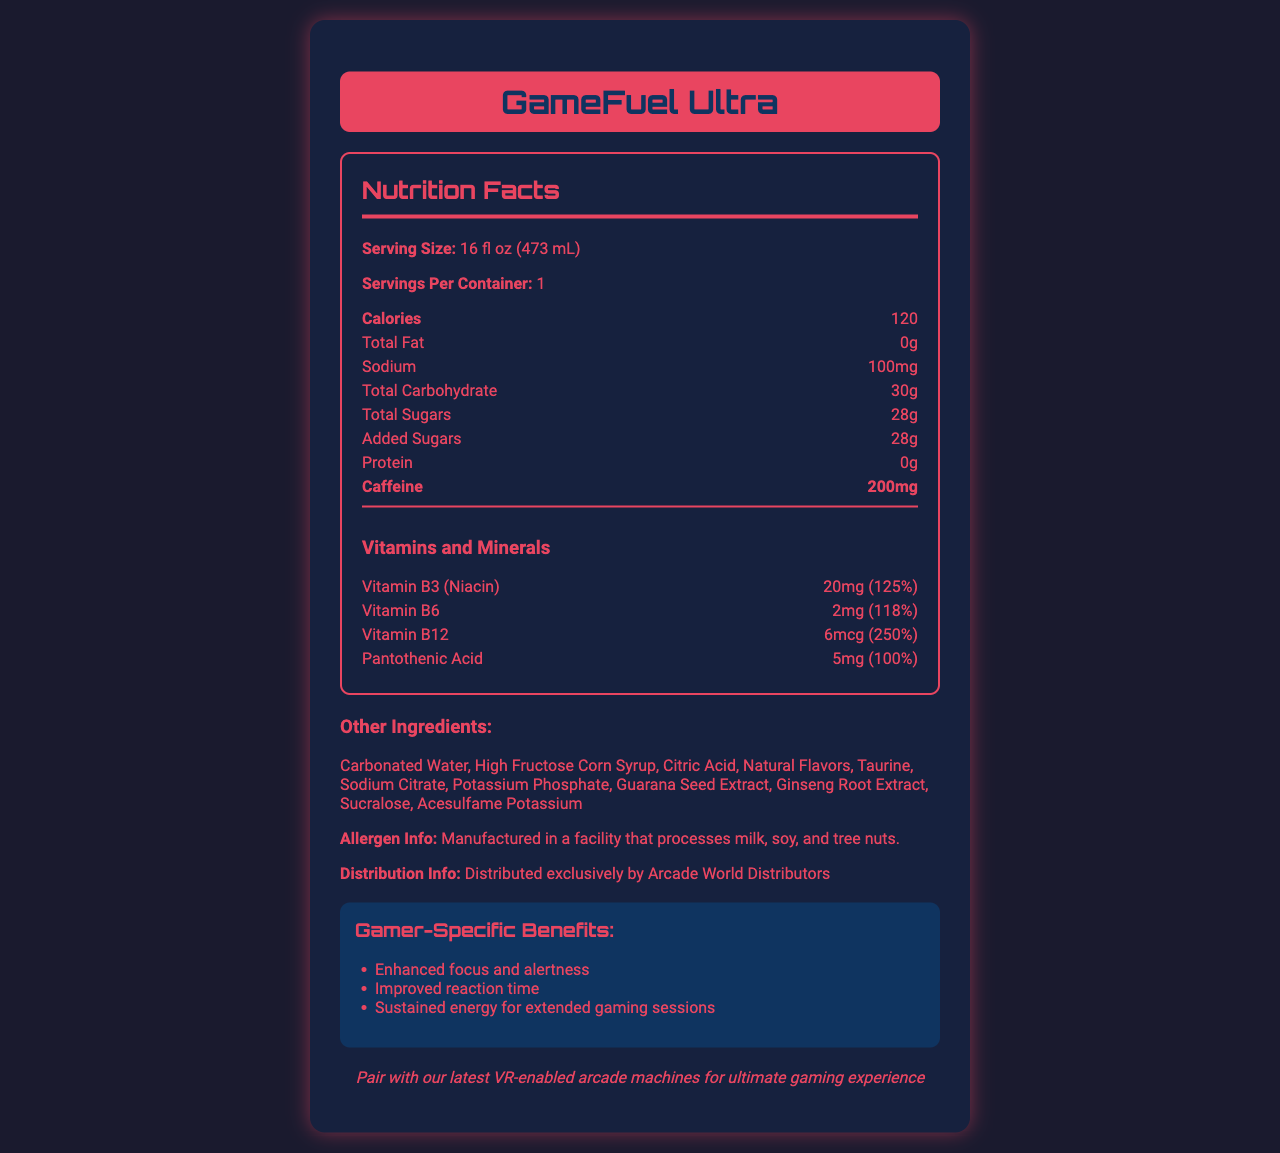what is the serving size of GameFuel Ultra? The document states that the serving size is "16 fl oz (473 mL)".
Answer: 16 fl oz (473 mL) how much caffeine does GameFuel Ultra contain per serving? The document lists the caffeine content as 200mg.
Answer: 200mg how many grams of total sugars are in GameFuel Ultra? The document states that the total sugars are 28g.
Answer: 28g how much sodium is present in one serving of GameFuel Ultra? The sodium content is listed as 100mg.
Answer: 100mg what is the calorie count for one container of GameFuel Ultra? The document specifies that the calorie count per serving is 120.
Answer: 120 which vitamin has the highest daily value percent in GameFuel Ultra? A. Vitamin B3 B. Vitamin B6 C. Vitamin B12 D. Pantothenic Acid Vitamin B12 has a daily value of 250%, which is the highest among the vitamins listed.
Answer: C. Vitamin B12 how many servings are there per container of GameFuel Ultra? A. 1 B. 2 C. 3 D. 4 The document states that there is 1 serving per container.
Answer: A. 1 does GameFuel Ultra contain any protein? The protein content is listed as 0g.
Answer: No is GameFuel Ultra manufactured in a facility that processes tree nuts? The allergen information states that it is manufactured in a facility that processes milk, soy, and tree nuts.
Answer: Yes summarize the main benefits of GameFuel Ultra mentioned in the document. The document mentions that GameFuel Ultra provides benefits such as enhanced focus and alertness, improved reaction time, and sustained energy for extended gaming sessions.
Answer: Enhanced focus and alertness, improved reaction time, sustained energy for extended gaming sessions who distributes GameFuel Ultra? The distribution information states that it is distributed exclusively by Arcade World Distributors.
Answer: Arcade World Distributors what is the daily value percentage of Pantothenic Acid in GameFuel Ultra? The document lists the daily value percentage of Pantothenic Acid as 100%.
Answer: 100% is GameFuel Ultra compatible with VR-enabled arcade machines? The document mentions that GameFuel Ultra can pair with VR-enabled arcade machines for an ultimate gaming experience.
Answer: Yes what specific ingredients add the flavors to GameFuel Ultra? The document lists "Natural Flavors" among the other ingredients.
Answer: Natural Flavors what is the purpose of the vitamins and minerals included in GameFuel Ultra? The vitamins and minerals such as Vitamin B3, Vitamin B6, Vitamin B12, and Pantothenic Acid help in providing essential nutrients needed for daily activities and overall health.
Answer: They help provide essential nutrients and support overall health. how much added sugar is in GameFuel Ultra? The document clearly states that there are 28g of added sugars.
Answer: 28g what are the vitamins and minerals included in GameFuel Ultra? The vitamins and minerals included are Vitamin B3 (Niacin), Vitamin B6, Vitamin B12, and Pantothenic Acid.
Answer: Vitamin B3, Vitamin B6, Vitamin B12, Pantothenic Acid are there any other variants of GameFuel Ultra listed in the document? The document does not provide any information about other variants of GameFuel Ultra.
Answer: Not enough information describe two main uses of GameFuel Ultra based on the document content. The document describes that GameFuel Ultra enhances focus and alertness, improves reaction time, and sustains energy. It also mentions that it can pair with VR-enabled arcade machines for an ultimate gaming experience.
Answer: Enhancing gaming performance and pairing with VR-enabled arcade machines 